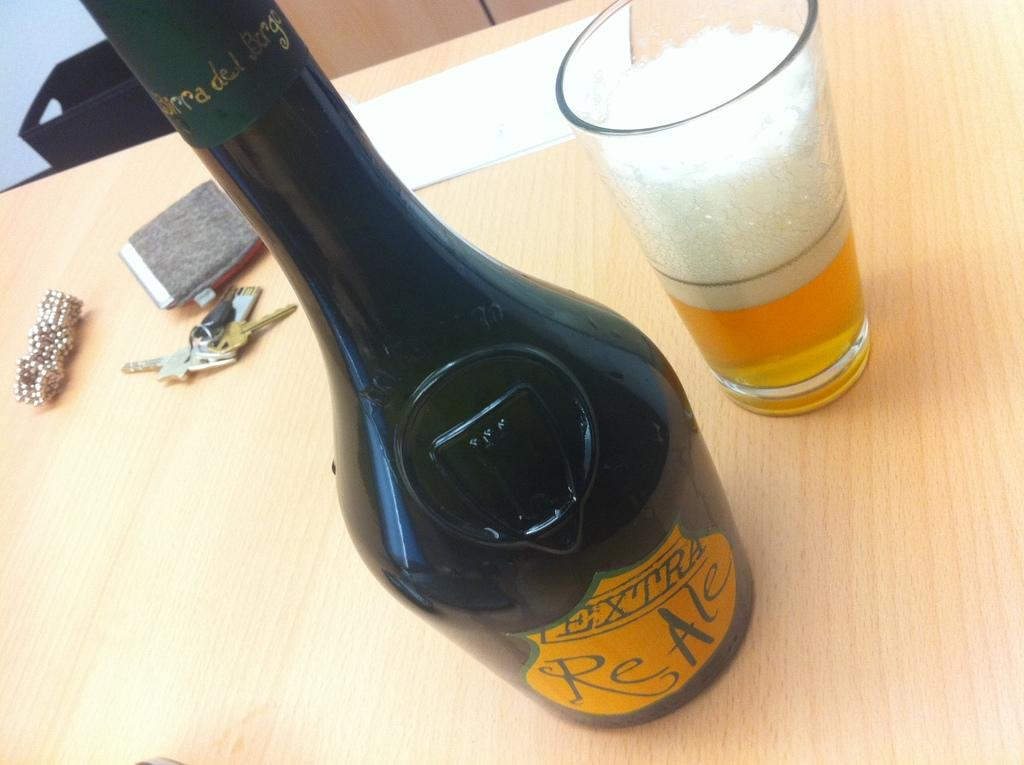What is one of the objects visible in the image? There is a bottle in the image. What else can be seen in the image? There is a glass in the image. What is the surface made of that the objects are placed on? The objects are placed on a wooden surface in the image. What type of air can be seen coming out of the bottle in the image? There is no air coming out of the bottle in the image. Is the glass hot to the touch in the image? The provided facts do not mention the temperature of the glass, so we cannot determine if it is hot or not. 